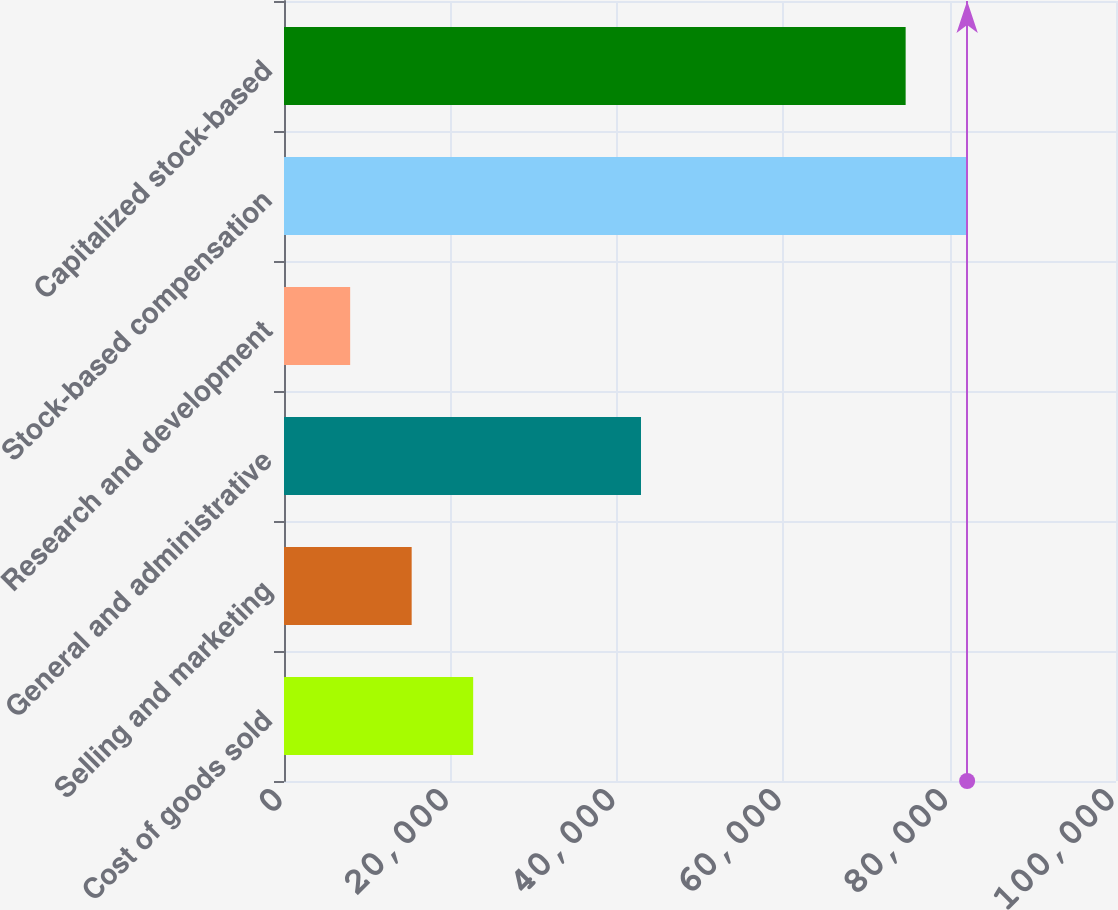Convert chart to OTSL. <chart><loc_0><loc_0><loc_500><loc_500><bar_chart><fcel>Cost of goods sold<fcel>Selling and marketing<fcel>General and administrative<fcel>Research and development<fcel>Stock-based compensation<fcel>Capitalized stock-based<nl><fcel>22737.4<fcel>15344.7<fcel>42908<fcel>7952<fcel>82109.7<fcel>74717<nl></chart> 